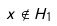Convert formula to latex. <formula><loc_0><loc_0><loc_500><loc_500>x \notin H _ { 1 }</formula> 